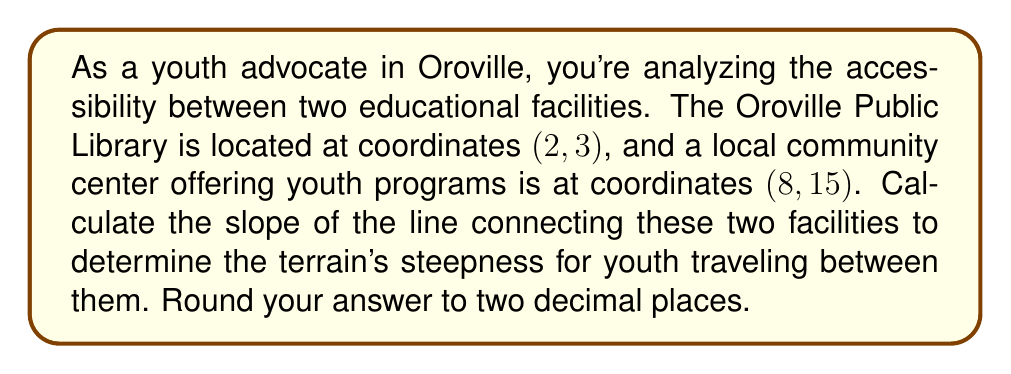Help me with this question. To solve this problem, we'll use the slope formula:

$$ m = \frac{y_2 - y_1}{x_2 - x_1} $$

Where $(x_1, y_1)$ represents the coordinates of the first point (Oroville Public Library) and $(x_2, y_2)$ represents the coordinates of the second point (community center).

Given:
- Oroville Public Library: $(2, 3)$
- Community Center: $(8, 15)$

Let's plug these values into the slope formula:

$$ m = \frac{15 - 3}{8 - 2} = \frac{12}{6} $$

Simplify the fraction:

$$ m = 2 $$

The slope is exactly 2, so no rounding is necessary in this case.

[asy]
unitsize(1cm);
draw((-1,-1)--(10,17),gray);
dot((2,3));
dot((8,15));
label("Library (2,3)", (2,3), SW);
label("Community Center (8,15)", (8,15), NE);
label("Slope = 2", (5,9), SE);
[/asy]

Interpretation: A slope of 2 means that for every 1 unit of horizontal distance, there is a 2-unit increase in vertical distance. This indicates a relatively steep incline between the two facilities, which might present some accessibility challenges for youth traveling between them.
Answer: The slope of the line connecting the two educational facilities is 2.00. 